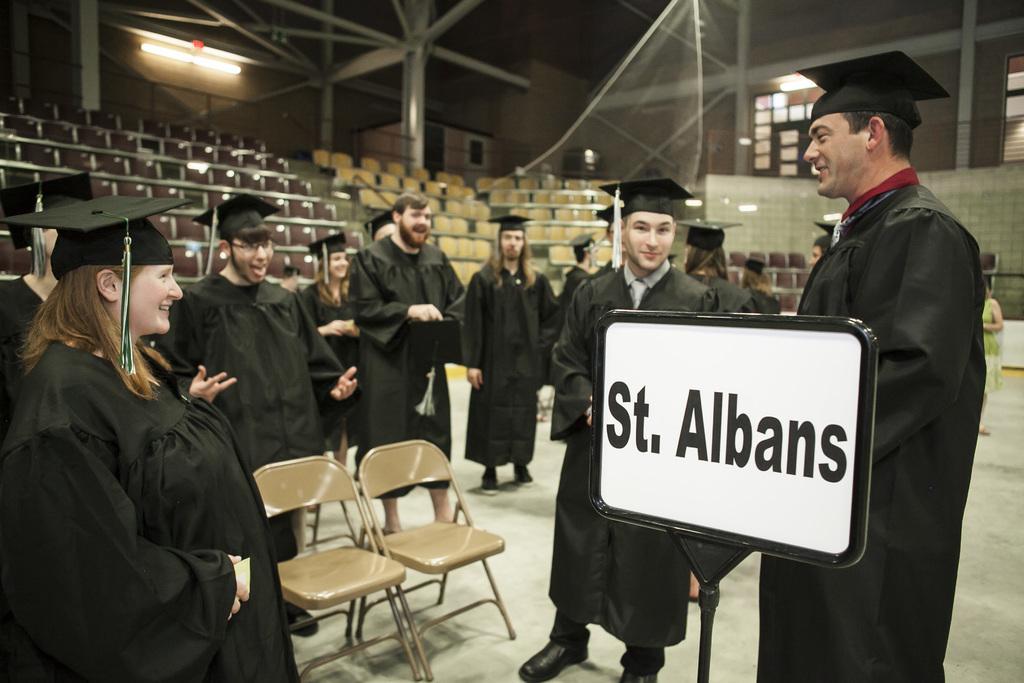Describe this image in one or two sentences. This is an inside view. Here I can see few people are wearing black color coats, caps on the heads, standing on the floor and everyone is smiling. On the right side, I can see a board on which I can see some text. There are two empty chairs on the floor. In the background, I can see few stairs and many empty chairs. At the top of the image there are few metal rods and I can see a light which is attached to the wall. 